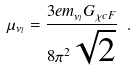Convert formula to latex. <formula><loc_0><loc_0><loc_500><loc_500>\mu _ { \nu _ { l } } = \frac { 3 e m _ { \nu _ { l } } G _ { \chi c F } } { 8 \pi ^ { 2 } \sqrt { 2 } } \ .</formula> 